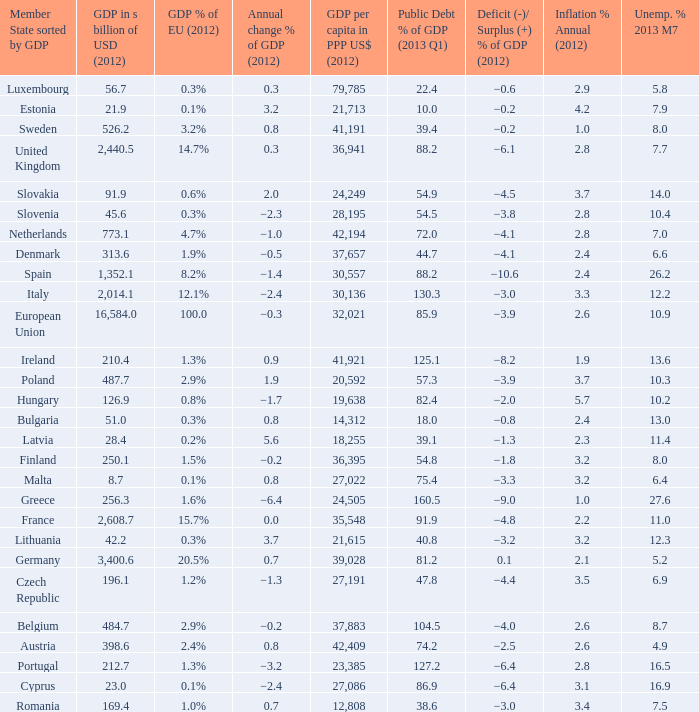What is the deficit/surplus % of the 2012 GDP of the country with a GDP in billions of USD in 2012 less than 1,352.1, a GDP per capita in PPP US dollars in 2012 greater than 21,615, public debt % of GDP in the 2013 Q1 less than 75.4, and an inflation % annual in 2012 of 2.9? −0.6. 